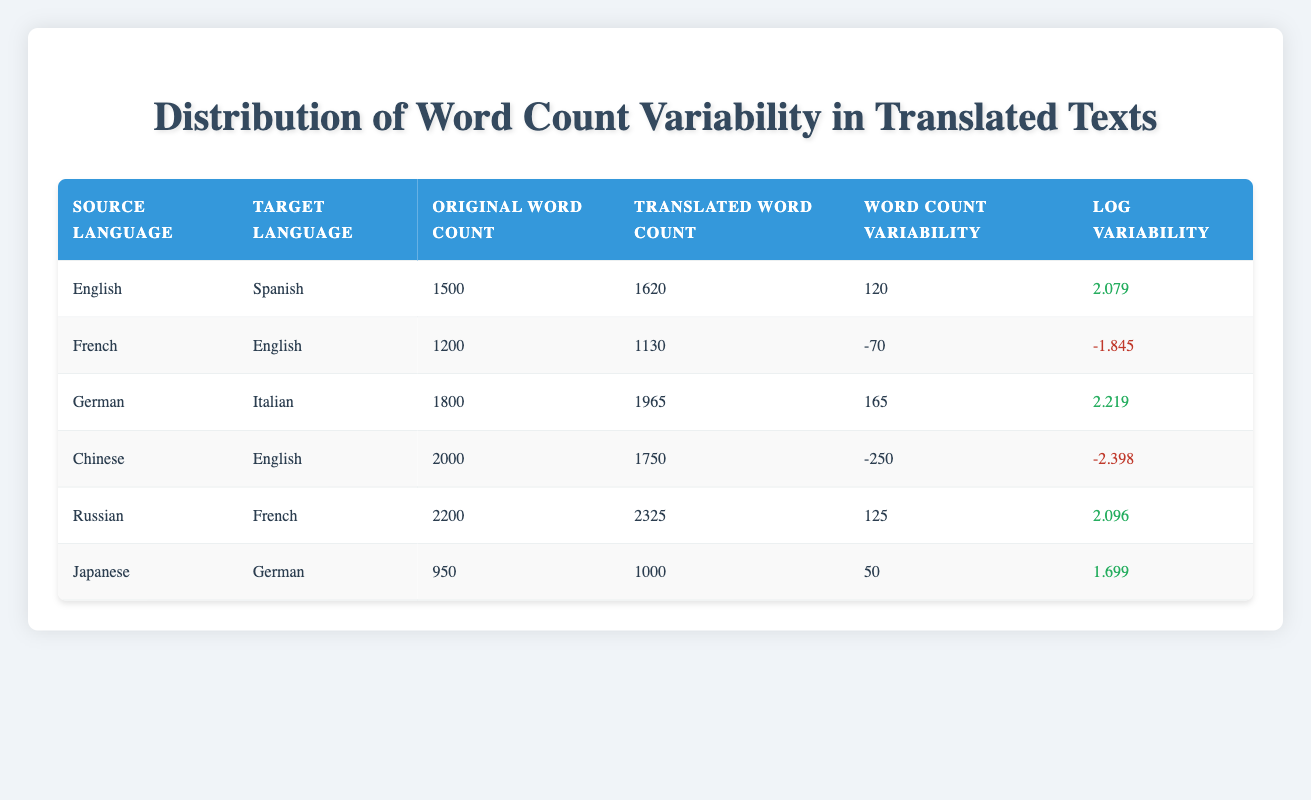What is the word count variability for the translation from English to Spanish? The table indicates that for the English to Spanish translation, the word count variability is 120.
Answer: 120 Which pair of source and target languages resulted in a negative word count variability? The translation from Chinese to English has a word count variability of -250, indicating a decrease in word count.
Answer: Chinese to English What is the log variability for the translation from German to Italian? The log variability for the German to Italian translation is presented as 2.219 in the table.
Answer: 2.219 How many languages resulted in a positive word count variability? Analyzing the table, there are four translations with positive word count variability values: English to Spanish, German to Italian, Russian to French, and Japanese to German.
Answer: 4 What is the average original word count from all the translations listed in the table? To find the average, add the original word counts: 1500 + 1200 + 1800 + 2000 + 2200 + 950 = 10650. Then divide by the number of translations (6): 10650 / 6 = 1775.
Answer: 1775 Did the translation from French to English maintain the original word count? The table shows that the original word count for French to English was 1200, while the translated word count is 1130, indicating a decrease and thus did not maintain the original word count.
Answer: No Which translation had the highest word count variability and what was that value? Comparing all the word count variability values, the translation from German to Italian has the highest variability of 165.
Answer: 165 Is there any translation that shows an increase in word count variability but a lower log variability? Between the translations, the one from Japanese to German shows an increase in word count variability (50) and has a lower log variability (1.699) compared to others like Russian to French which has higher variability (125) but a slightly higher log (2.096).
Answer: Yes 